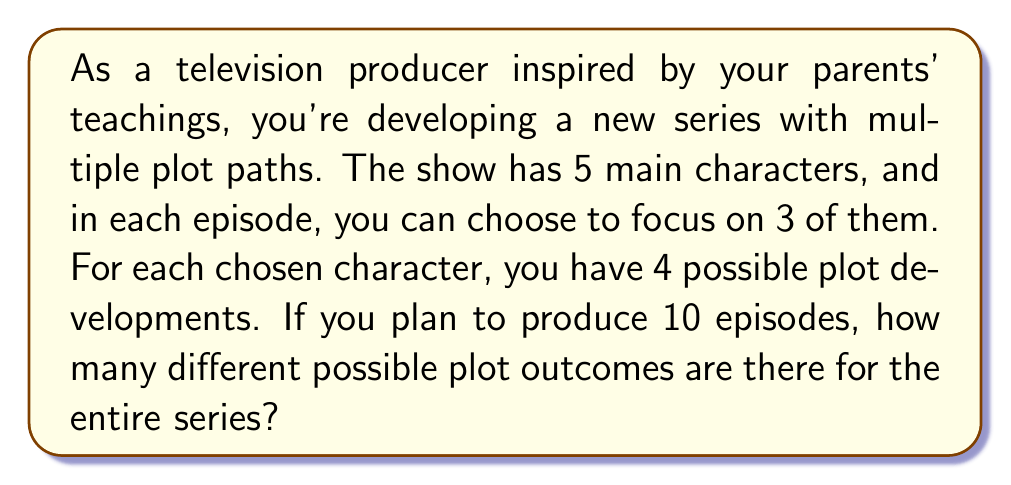Can you solve this math problem? Let's break this down step-by-step:

1) First, we need to calculate how many ways we can choose 3 characters out of 5 for each episode. This is a combination problem:

   $${5 \choose 3} = \frac{5!}{3!(5-3)!} = \frac{5!}{3!2!} = 10$$

2) For each chosen character, there are 4 possible plot developments. Since we're choosing 3 characters per episode, the number of possible plot combinations for a single episode is:

   $$4^3 = 64$$

3) Now, we have 10 episodes, and for each episode, we have 10 ways to choose characters and 64 ways to develop their plots. This means for the entire series, we have:

   $$(10 \times 64)^{10}$$

4) Let's calculate this:
   
   $$(10 \times 64)^{10} = 640^{10} = 1.2388289532\times 10^{28}$$

This astronomical number represents the power of storytelling and the vast possibilities that come from combining different characters and plot developments, much like how your parents' diverse teachings have influenced your creative process.
Answer: $$1.2388289532\times 10^{28}$$ possible plot outcomes 